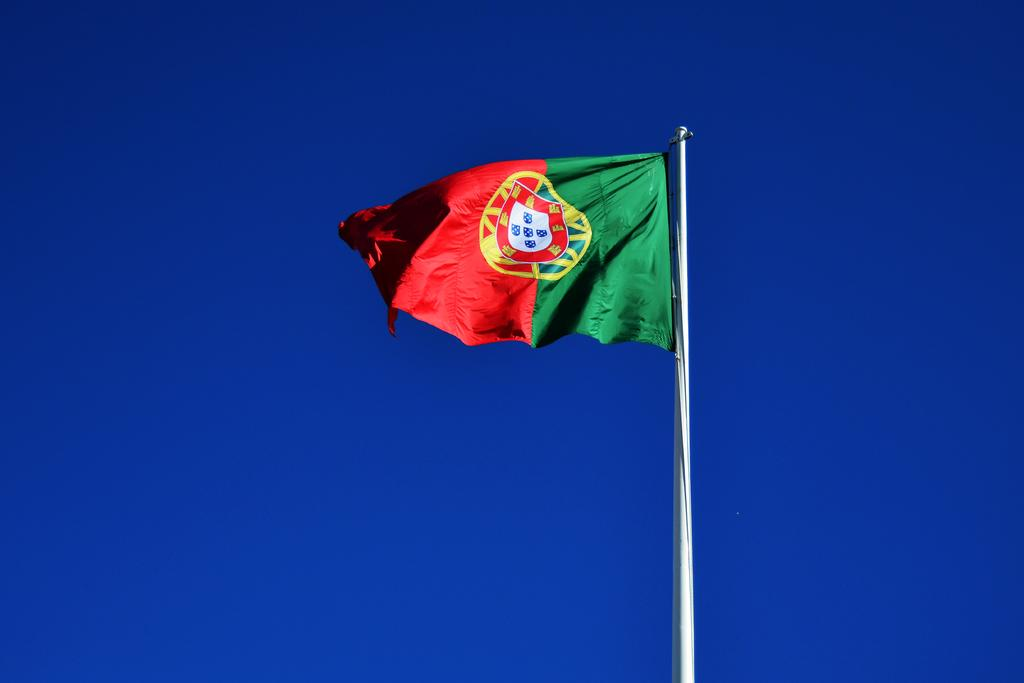What is the main object in the foreground of the image? There is a flag in the foreground of the image. How is the flag supported or held up? The flag is attached to a pole. What color is the background of the image? The background of the image is blue. What type of chain can be seen hanging from the flag in the image? There is no chain present in the image; the flag is attached to a pole. Are there any pickles visible in the image? There are no pickles present in the image. 